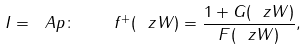<formula> <loc_0><loc_0><loc_500><loc_500>I = \ A p \colon \quad f ^ { + } ( \ z W ) = \frac { 1 + G ( \ z W ) } { F ( \ z W ) } ,</formula> 